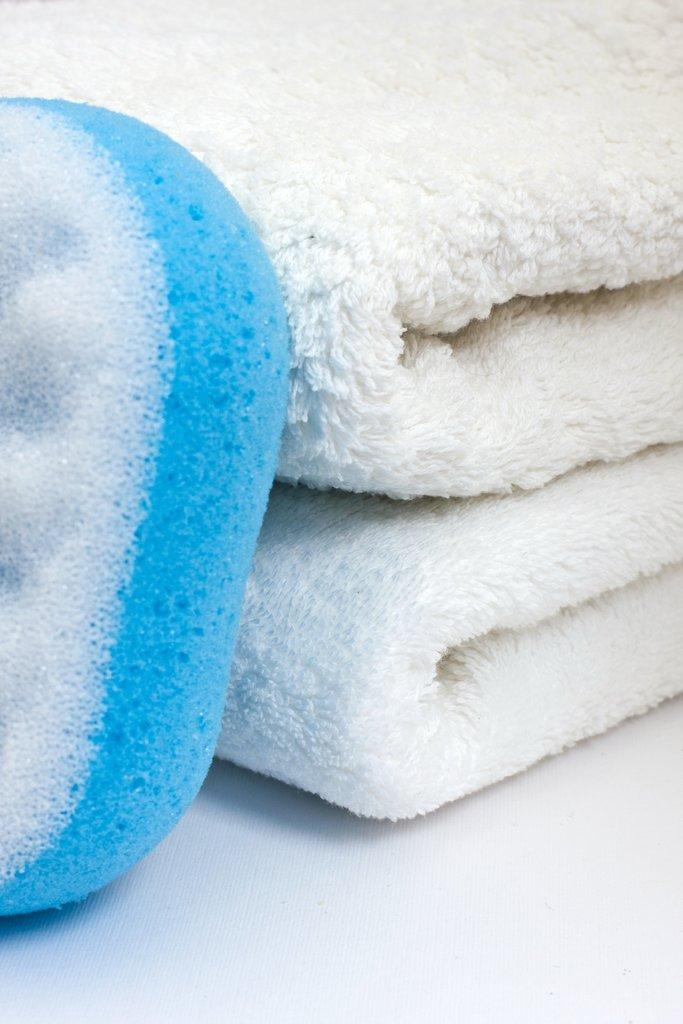What can be seen in the image that is related to cleaning or bathing? There are folded towels and a sponge scrub in the image. Where are the folded towels and sponge scrub located? They are placed on a surface in the image. What type of creature is crawling on the folded towels in the image? There is no creature present on the folded towels in the image. 